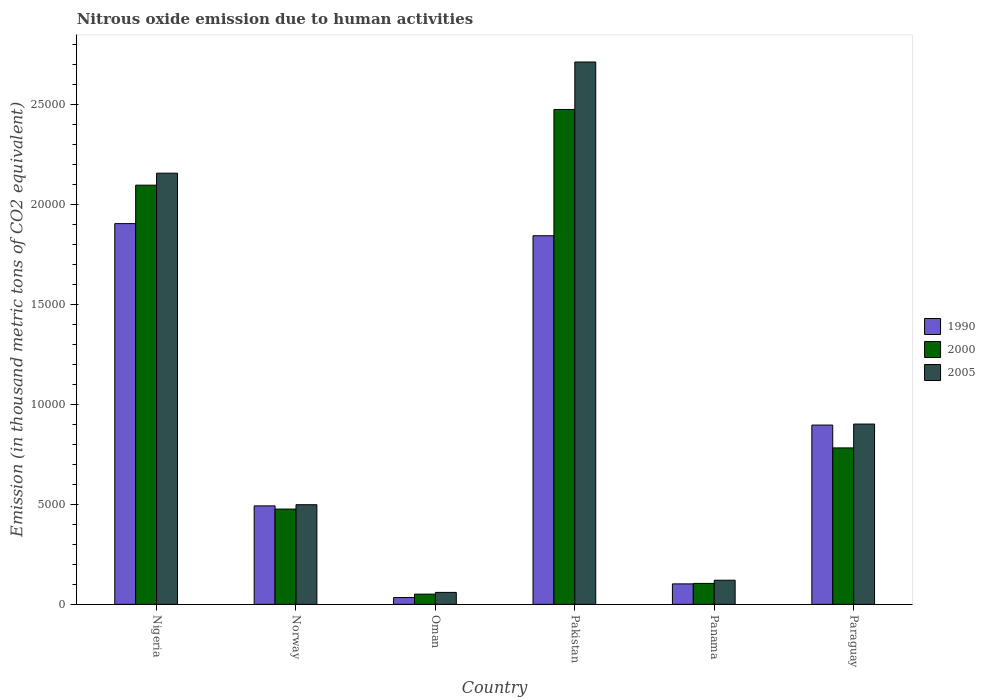How many different coloured bars are there?
Offer a terse response. 3. How many groups of bars are there?
Offer a terse response. 6. What is the label of the 6th group of bars from the left?
Offer a very short reply. Paraguay. In how many cases, is the number of bars for a given country not equal to the number of legend labels?
Your answer should be compact. 0. What is the amount of nitrous oxide emitted in 2000 in Oman?
Keep it short and to the point. 510.6. Across all countries, what is the maximum amount of nitrous oxide emitted in 2005?
Offer a terse response. 2.71e+04. Across all countries, what is the minimum amount of nitrous oxide emitted in 2005?
Your answer should be compact. 597.3. In which country was the amount of nitrous oxide emitted in 2000 minimum?
Your answer should be compact. Oman. What is the total amount of nitrous oxide emitted in 2005 in the graph?
Provide a short and direct response. 6.45e+04. What is the difference between the amount of nitrous oxide emitted in 1990 in Pakistan and that in Panama?
Offer a terse response. 1.74e+04. What is the difference between the amount of nitrous oxide emitted in 2000 in Pakistan and the amount of nitrous oxide emitted in 1990 in Paraguay?
Give a very brief answer. 1.58e+04. What is the average amount of nitrous oxide emitted in 1990 per country?
Ensure brevity in your answer.  8790.95. What is the difference between the amount of nitrous oxide emitted of/in 1990 and amount of nitrous oxide emitted of/in 2000 in Norway?
Provide a short and direct response. 159.5. In how many countries, is the amount of nitrous oxide emitted in 1990 greater than 19000 thousand metric tons?
Provide a succinct answer. 1. What is the ratio of the amount of nitrous oxide emitted in 2005 in Panama to that in Paraguay?
Keep it short and to the point. 0.13. Is the amount of nitrous oxide emitted in 1990 in Norway less than that in Oman?
Provide a succinct answer. No. Is the difference between the amount of nitrous oxide emitted in 1990 in Norway and Panama greater than the difference between the amount of nitrous oxide emitted in 2000 in Norway and Panama?
Your answer should be very brief. Yes. What is the difference between the highest and the second highest amount of nitrous oxide emitted in 2005?
Keep it short and to the point. -1.26e+04. What is the difference between the highest and the lowest amount of nitrous oxide emitted in 2000?
Your answer should be compact. 2.42e+04. In how many countries, is the amount of nitrous oxide emitted in 2000 greater than the average amount of nitrous oxide emitted in 2000 taken over all countries?
Offer a very short reply. 2. Is the sum of the amount of nitrous oxide emitted in 2005 in Norway and Pakistan greater than the maximum amount of nitrous oxide emitted in 1990 across all countries?
Keep it short and to the point. Yes. What does the 2nd bar from the left in Paraguay represents?
Your answer should be compact. 2000. What does the 3rd bar from the right in Oman represents?
Provide a short and direct response. 1990. How many countries are there in the graph?
Keep it short and to the point. 6. What is the difference between two consecutive major ticks on the Y-axis?
Offer a terse response. 5000. Are the values on the major ticks of Y-axis written in scientific E-notation?
Make the answer very short. No. Does the graph contain any zero values?
Make the answer very short. No. Where does the legend appear in the graph?
Your answer should be compact. Center right. What is the title of the graph?
Your answer should be very brief. Nitrous oxide emission due to human activities. Does "2003" appear as one of the legend labels in the graph?
Offer a very short reply. No. What is the label or title of the Y-axis?
Ensure brevity in your answer.  Emission (in thousand metric tons of CO2 equivalent). What is the Emission (in thousand metric tons of CO2 equivalent) of 1990 in Nigeria?
Your answer should be very brief. 1.90e+04. What is the Emission (in thousand metric tons of CO2 equivalent) in 2000 in Nigeria?
Offer a terse response. 2.10e+04. What is the Emission (in thousand metric tons of CO2 equivalent) of 2005 in Nigeria?
Make the answer very short. 2.16e+04. What is the Emission (in thousand metric tons of CO2 equivalent) in 1990 in Norway?
Provide a succinct answer. 4925.7. What is the Emission (in thousand metric tons of CO2 equivalent) in 2000 in Norway?
Give a very brief answer. 4766.2. What is the Emission (in thousand metric tons of CO2 equivalent) in 2005 in Norway?
Provide a short and direct response. 4984.5. What is the Emission (in thousand metric tons of CO2 equivalent) in 1990 in Oman?
Make the answer very short. 338.2. What is the Emission (in thousand metric tons of CO2 equivalent) in 2000 in Oman?
Provide a short and direct response. 510.6. What is the Emission (in thousand metric tons of CO2 equivalent) in 2005 in Oman?
Give a very brief answer. 597.3. What is the Emission (in thousand metric tons of CO2 equivalent) in 1990 in Pakistan?
Keep it short and to the point. 1.84e+04. What is the Emission (in thousand metric tons of CO2 equivalent) of 2000 in Pakistan?
Your answer should be very brief. 2.48e+04. What is the Emission (in thousand metric tons of CO2 equivalent) of 2005 in Pakistan?
Provide a short and direct response. 2.71e+04. What is the Emission (in thousand metric tons of CO2 equivalent) of 1990 in Panama?
Your answer should be compact. 1023.3. What is the Emission (in thousand metric tons of CO2 equivalent) in 2000 in Panama?
Keep it short and to the point. 1046.4. What is the Emission (in thousand metric tons of CO2 equivalent) in 2005 in Panama?
Provide a succinct answer. 1207.1. What is the Emission (in thousand metric tons of CO2 equivalent) in 1990 in Paraguay?
Provide a succinct answer. 8968.7. What is the Emission (in thousand metric tons of CO2 equivalent) in 2000 in Paraguay?
Give a very brief answer. 7826.3. What is the Emission (in thousand metric tons of CO2 equivalent) in 2005 in Paraguay?
Keep it short and to the point. 9019.7. Across all countries, what is the maximum Emission (in thousand metric tons of CO2 equivalent) in 1990?
Keep it short and to the point. 1.90e+04. Across all countries, what is the maximum Emission (in thousand metric tons of CO2 equivalent) in 2000?
Your response must be concise. 2.48e+04. Across all countries, what is the maximum Emission (in thousand metric tons of CO2 equivalent) in 2005?
Ensure brevity in your answer.  2.71e+04. Across all countries, what is the minimum Emission (in thousand metric tons of CO2 equivalent) of 1990?
Provide a succinct answer. 338.2. Across all countries, what is the minimum Emission (in thousand metric tons of CO2 equivalent) of 2000?
Ensure brevity in your answer.  510.6. Across all countries, what is the minimum Emission (in thousand metric tons of CO2 equivalent) of 2005?
Your answer should be compact. 597.3. What is the total Emission (in thousand metric tons of CO2 equivalent) in 1990 in the graph?
Your answer should be compact. 5.27e+04. What is the total Emission (in thousand metric tons of CO2 equivalent) in 2000 in the graph?
Ensure brevity in your answer.  5.99e+04. What is the total Emission (in thousand metric tons of CO2 equivalent) of 2005 in the graph?
Provide a short and direct response. 6.45e+04. What is the difference between the Emission (in thousand metric tons of CO2 equivalent) in 1990 in Nigeria and that in Norway?
Offer a terse response. 1.41e+04. What is the difference between the Emission (in thousand metric tons of CO2 equivalent) of 2000 in Nigeria and that in Norway?
Ensure brevity in your answer.  1.62e+04. What is the difference between the Emission (in thousand metric tons of CO2 equivalent) of 2005 in Nigeria and that in Norway?
Provide a short and direct response. 1.66e+04. What is the difference between the Emission (in thousand metric tons of CO2 equivalent) in 1990 in Nigeria and that in Oman?
Your response must be concise. 1.87e+04. What is the difference between the Emission (in thousand metric tons of CO2 equivalent) of 2000 in Nigeria and that in Oman?
Offer a very short reply. 2.05e+04. What is the difference between the Emission (in thousand metric tons of CO2 equivalent) of 2005 in Nigeria and that in Oman?
Provide a succinct answer. 2.10e+04. What is the difference between the Emission (in thousand metric tons of CO2 equivalent) in 1990 in Nigeria and that in Pakistan?
Offer a very short reply. 606.4. What is the difference between the Emission (in thousand metric tons of CO2 equivalent) in 2000 in Nigeria and that in Pakistan?
Offer a terse response. -3787.6. What is the difference between the Emission (in thousand metric tons of CO2 equivalent) in 2005 in Nigeria and that in Pakistan?
Provide a short and direct response. -5562. What is the difference between the Emission (in thousand metric tons of CO2 equivalent) of 1990 in Nigeria and that in Panama?
Your answer should be very brief. 1.80e+04. What is the difference between the Emission (in thousand metric tons of CO2 equivalent) of 2000 in Nigeria and that in Panama?
Keep it short and to the point. 1.99e+04. What is the difference between the Emission (in thousand metric tons of CO2 equivalent) in 2005 in Nigeria and that in Panama?
Your answer should be very brief. 2.04e+04. What is the difference between the Emission (in thousand metric tons of CO2 equivalent) of 1990 in Nigeria and that in Paraguay?
Offer a terse response. 1.01e+04. What is the difference between the Emission (in thousand metric tons of CO2 equivalent) in 2000 in Nigeria and that in Paraguay?
Keep it short and to the point. 1.31e+04. What is the difference between the Emission (in thousand metric tons of CO2 equivalent) in 2005 in Nigeria and that in Paraguay?
Make the answer very short. 1.26e+04. What is the difference between the Emission (in thousand metric tons of CO2 equivalent) in 1990 in Norway and that in Oman?
Make the answer very short. 4587.5. What is the difference between the Emission (in thousand metric tons of CO2 equivalent) in 2000 in Norway and that in Oman?
Offer a very short reply. 4255.6. What is the difference between the Emission (in thousand metric tons of CO2 equivalent) of 2005 in Norway and that in Oman?
Give a very brief answer. 4387.2. What is the difference between the Emission (in thousand metric tons of CO2 equivalent) of 1990 in Norway and that in Pakistan?
Provide a short and direct response. -1.35e+04. What is the difference between the Emission (in thousand metric tons of CO2 equivalent) of 2000 in Norway and that in Pakistan?
Provide a succinct answer. -2.00e+04. What is the difference between the Emission (in thousand metric tons of CO2 equivalent) in 2005 in Norway and that in Pakistan?
Provide a succinct answer. -2.22e+04. What is the difference between the Emission (in thousand metric tons of CO2 equivalent) in 1990 in Norway and that in Panama?
Make the answer very short. 3902.4. What is the difference between the Emission (in thousand metric tons of CO2 equivalent) in 2000 in Norway and that in Panama?
Your response must be concise. 3719.8. What is the difference between the Emission (in thousand metric tons of CO2 equivalent) in 2005 in Norway and that in Panama?
Ensure brevity in your answer.  3777.4. What is the difference between the Emission (in thousand metric tons of CO2 equivalent) in 1990 in Norway and that in Paraguay?
Keep it short and to the point. -4043. What is the difference between the Emission (in thousand metric tons of CO2 equivalent) in 2000 in Norway and that in Paraguay?
Keep it short and to the point. -3060.1. What is the difference between the Emission (in thousand metric tons of CO2 equivalent) of 2005 in Norway and that in Paraguay?
Give a very brief answer. -4035.2. What is the difference between the Emission (in thousand metric tons of CO2 equivalent) of 1990 in Oman and that in Pakistan?
Provide a succinct answer. -1.81e+04. What is the difference between the Emission (in thousand metric tons of CO2 equivalent) in 2000 in Oman and that in Pakistan?
Ensure brevity in your answer.  -2.42e+04. What is the difference between the Emission (in thousand metric tons of CO2 equivalent) in 2005 in Oman and that in Pakistan?
Your answer should be compact. -2.65e+04. What is the difference between the Emission (in thousand metric tons of CO2 equivalent) in 1990 in Oman and that in Panama?
Your answer should be very brief. -685.1. What is the difference between the Emission (in thousand metric tons of CO2 equivalent) in 2000 in Oman and that in Panama?
Provide a succinct answer. -535.8. What is the difference between the Emission (in thousand metric tons of CO2 equivalent) in 2005 in Oman and that in Panama?
Ensure brevity in your answer.  -609.8. What is the difference between the Emission (in thousand metric tons of CO2 equivalent) of 1990 in Oman and that in Paraguay?
Your answer should be compact. -8630.5. What is the difference between the Emission (in thousand metric tons of CO2 equivalent) in 2000 in Oman and that in Paraguay?
Keep it short and to the point. -7315.7. What is the difference between the Emission (in thousand metric tons of CO2 equivalent) in 2005 in Oman and that in Paraguay?
Provide a succinct answer. -8422.4. What is the difference between the Emission (in thousand metric tons of CO2 equivalent) in 1990 in Pakistan and that in Panama?
Keep it short and to the point. 1.74e+04. What is the difference between the Emission (in thousand metric tons of CO2 equivalent) of 2000 in Pakistan and that in Panama?
Give a very brief answer. 2.37e+04. What is the difference between the Emission (in thousand metric tons of CO2 equivalent) of 2005 in Pakistan and that in Panama?
Make the answer very short. 2.59e+04. What is the difference between the Emission (in thousand metric tons of CO2 equivalent) of 1990 in Pakistan and that in Paraguay?
Your answer should be compact. 9473. What is the difference between the Emission (in thousand metric tons of CO2 equivalent) of 2000 in Pakistan and that in Paraguay?
Your answer should be very brief. 1.69e+04. What is the difference between the Emission (in thousand metric tons of CO2 equivalent) in 2005 in Pakistan and that in Paraguay?
Give a very brief answer. 1.81e+04. What is the difference between the Emission (in thousand metric tons of CO2 equivalent) in 1990 in Panama and that in Paraguay?
Provide a succinct answer. -7945.4. What is the difference between the Emission (in thousand metric tons of CO2 equivalent) of 2000 in Panama and that in Paraguay?
Offer a terse response. -6779.9. What is the difference between the Emission (in thousand metric tons of CO2 equivalent) in 2005 in Panama and that in Paraguay?
Your response must be concise. -7812.6. What is the difference between the Emission (in thousand metric tons of CO2 equivalent) in 1990 in Nigeria and the Emission (in thousand metric tons of CO2 equivalent) in 2000 in Norway?
Your answer should be very brief. 1.43e+04. What is the difference between the Emission (in thousand metric tons of CO2 equivalent) of 1990 in Nigeria and the Emission (in thousand metric tons of CO2 equivalent) of 2005 in Norway?
Offer a very short reply. 1.41e+04. What is the difference between the Emission (in thousand metric tons of CO2 equivalent) in 2000 in Nigeria and the Emission (in thousand metric tons of CO2 equivalent) in 2005 in Norway?
Your response must be concise. 1.60e+04. What is the difference between the Emission (in thousand metric tons of CO2 equivalent) in 1990 in Nigeria and the Emission (in thousand metric tons of CO2 equivalent) in 2000 in Oman?
Keep it short and to the point. 1.85e+04. What is the difference between the Emission (in thousand metric tons of CO2 equivalent) in 1990 in Nigeria and the Emission (in thousand metric tons of CO2 equivalent) in 2005 in Oman?
Keep it short and to the point. 1.85e+04. What is the difference between the Emission (in thousand metric tons of CO2 equivalent) in 2000 in Nigeria and the Emission (in thousand metric tons of CO2 equivalent) in 2005 in Oman?
Offer a very short reply. 2.04e+04. What is the difference between the Emission (in thousand metric tons of CO2 equivalent) of 1990 in Nigeria and the Emission (in thousand metric tons of CO2 equivalent) of 2000 in Pakistan?
Your answer should be compact. -5711.6. What is the difference between the Emission (in thousand metric tons of CO2 equivalent) of 1990 in Nigeria and the Emission (in thousand metric tons of CO2 equivalent) of 2005 in Pakistan?
Provide a short and direct response. -8086.4. What is the difference between the Emission (in thousand metric tons of CO2 equivalent) in 2000 in Nigeria and the Emission (in thousand metric tons of CO2 equivalent) in 2005 in Pakistan?
Your response must be concise. -6162.4. What is the difference between the Emission (in thousand metric tons of CO2 equivalent) in 1990 in Nigeria and the Emission (in thousand metric tons of CO2 equivalent) in 2000 in Panama?
Offer a very short reply. 1.80e+04. What is the difference between the Emission (in thousand metric tons of CO2 equivalent) of 1990 in Nigeria and the Emission (in thousand metric tons of CO2 equivalent) of 2005 in Panama?
Your response must be concise. 1.78e+04. What is the difference between the Emission (in thousand metric tons of CO2 equivalent) in 2000 in Nigeria and the Emission (in thousand metric tons of CO2 equivalent) in 2005 in Panama?
Your answer should be very brief. 1.98e+04. What is the difference between the Emission (in thousand metric tons of CO2 equivalent) in 1990 in Nigeria and the Emission (in thousand metric tons of CO2 equivalent) in 2000 in Paraguay?
Offer a very short reply. 1.12e+04. What is the difference between the Emission (in thousand metric tons of CO2 equivalent) of 1990 in Nigeria and the Emission (in thousand metric tons of CO2 equivalent) of 2005 in Paraguay?
Offer a terse response. 1.00e+04. What is the difference between the Emission (in thousand metric tons of CO2 equivalent) of 2000 in Nigeria and the Emission (in thousand metric tons of CO2 equivalent) of 2005 in Paraguay?
Give a very brief answer. 1.20e+04. What is the difference between the Emission (in thousand metric tons of CO2 equivalent) in 1990 in Norway and the Emission (in thousand metric tons of CO2 equivalent) in 2000 in Oman?
Your answer should be very brief. 4415.1. What is the difference between the Emission (in thousand metric tons of CO2 equivalent) in 1990 in Norway and the Emission (in thousand metric tons of CO2 equivalent) in 2005 in Oman?
Provide a succinct answer. 4328.4. What is the difference between the Emission (in thousand metric tons of CO2 equivalent) of 2000 in Norway and the Emission (in thousand metric tons of CO2 equivalent) of 2005 in Oman?
Ensure brevity in your answer.  4168.9. What is the difference between the Emission (in thousand metric tons of CO2 equivalent) of 1990 in Norway and the Emission (in thousand metric tons of CO2 equivalent) of 2000 in Pakistan?
Offer a very short reply. -1.98e+04. What is the difference between the Emission (in thousand metric tons of CO2 equivalent) of 1990 in Norway and the Emission (in thousand metric tons of CO2 equivalent) of 2005 in Pakistan?
Your answer should be very brief. -2.22e+04. What is the difference between the Emission (in thousand metric tons of CO2 equivalent) of 2000 in Norway and the Emission (in thousand metric tons of CO2 equivalent) of 2005 in Pakistan?
Provide a short and direct response. -2.24e+04. What is the difference between the Emission (in thousand metric tons of CO2 equivalent) of 1990 in Norway and the Emission (in thousand metric tons of CO2 equivalent) of 2000 in Panama?
Your response must be concise. 3879.3. What is the difference between the Emission (in thousand metric tons of CO2 equivalent) of 1990 in Norway and the Emission (in thousand metric tons of CO2 equivalent) of 2005 in Panama?
Ensure brevity in your answer.  3718.6. What is the difference between the Emission (in thousand metric tons of CO2 equivalent) in 2000 in Norway and the Emission (in thousand metric tons of CO2 equivalent) in 2005 in Panama?
Give a very brief answer. 3559.1. What is the difference between the Emission (in thousand metric tons of CO2 equivalent) of 1990 in Norway and the Emission (in thousand metric tons of CO2 equivalent) of 2000 in Paraguay?
Offer a very short reply. -2900.6. What is the difference between the Emission (in thousand metric tons of CO2 equivalent) in 1990 in Norway and the Emission (in thousand metric tons of CO2 equivalent) in 2005 in Paraguay?
Keep it short and to the point. -4094. What is the difference between the Emission (in thousand metric tons of CO2 equivalent) of 2000 in Norway and the Emission (in thousand metric tons of CO2 equivalent) of 2005 in Paraguay?
Your response must be concise. -4253.5. What is the difference between the Emission (in thousand metric tons of CO2 equivalent) of 1990 in Oman and the Emission (in thousand metric tons of CO2 equivalent) of 2000 in Pakistan?
Your response must be concise. -2.44e+04. What is the difference between the Emission (in thousand metric tons of CO2 equivalent) in 1990 in Oman and the Emission (in thousand metric tons of CO2 equivalent) in 2005 in Pakistan?
Keep it short and to the point. -2.68e+04. What is the difference between the Emission (in thousand metric tons of CO2 equivalent) of 2000 in Oman and the Emission (in thousand metric tons of CO2 equivalent) of 2005 in Pakistan?
Provide a succinct answer. -2.66e+04. What is the difference between the Emission (in thousand metric tons of CO2 equivalent) in 1990 in Oman and the Emission (in thousand metric tons of CO2 equivalent) in 2000 in Panama?
Provide a succinct answer. -708.2. What is the difference between the Emission (in thousand metric tons of CO2 equivalent) in 1990 in Oman and the Emission (in thousand metric tons of CO2 equivalent) in 2005 in Panama?
Your response must be concise. -868.9. What is the difference between the Emission (in thousand metric tons of CO2 equivalent) in 2000 in Oman and the Emission (in thousand metric tons of CO2 equivalent) in 2005 in Panama?
Make the answer very short. -696.5. What is the difference between the Emission (in thousand metric tons of CO2 equivalent) in 1990 in Oman and the Emission (in thousand metric tons of CO2 equivalent) in 2000 in Paraguay?
Your answer should be very brief. -7488.1. What is the difference between the Emission (in thousand metric tons of CO2 equivalent) in 1990 in Oman and the Emission (in thousand metric tons of CO2 equivalent) in 2005 in Paraguay?
Give a very brief answer. -8681.5. What is the difference between the Emission (in thousand metric tons of CO2 equivalent) in 2000 in Oman and the Emission (in thousand metric tons of CO2 equivalent) in 2005 in Paraguay?
Ensure brevity in your answer.  -8509.1. What is the difference between the Emission (in thousand metric tons of CO2 equivalent) of 1990 in Pakistan and the Emission (in thousand metric tons of CO2 equivalent) of 2000 in Panama?
Your answer should be very brief. 1.74e+04. What is the difference between the Emission (in thousand metric tons of CO2 equivalent) in 1990 in Pakistan and the Emission (in thousand metric tons of CO2 equivalent) in 2005 in Panama?
Your answer should be compact. 1.72e+04. What is the difference between the Emission (in thousand metric tons of CO2 equivalent) of 2000 in Pakistan and the Emission (in thousand metric tons of CO2 equivalent) of 2005 in Panama?
Your answer should be compact. 2.36e+04. What is the difference between the Emission (in thousand metric tons of CO2 equivalent) in 1990 in Pakistan and the Emission (in thousand metric tons of CO2 equivalent) in 2000 in Paraguay?
Offer a terse response. 1.06e+04. What is the difference between the Emission (in thousand metric tons of CO2 equivalent) in 1990 in Pakistan and the Emission (in thousand metric tons of CO2 equivalent) in 2005 in Paraguay?
Provide a succinct answer. 9422. What is the difference between the Emission (in thousand metric tons of CO2 equivalent) in 2000 in Pakistan and the Emission (in thousand metric tons of CO2 equivalent) in 2005 in Paraguay?
Offer a terse response. 1.57e+04. What is the difference between the Emission (in thousand metric tons of CO2 equivalent) in 1990 in Panama and the Emission (in thousand metric tons of CO2 equivalent) in 2000 in Paraguay?
Offer a very short reply. -6803. What is the difference between the Emission (in thousand metric tons of CO2 equivalent) of 1990 in Panama and the Emission (in thousand metric tons of CO2 equivalent) of 2005 in Paraguay?
Provide a succinct answer. -7996.4. What is the difference between the Emission (in thousand metric tons of CO2 equivalent) of 2000 in Panama and the Emission (in thousand metric tons of CO2 equivalent) of 2005 in Paraguay?
Give a very brief answer. -7973.3. What is the average Emission (in thousand metric tons of CO2 equivalent) in 1990 per country?
Provide a succinct answer. 8790.95. What is the average Emission (in thousand metric tons of CO2 equivalent) in 2000 per country?
Offer a terse response. 9980.22. What is the average Emission (in thousand metric tons of CO2 equivalent) of 2005 per country?
Your response must be concise. 1.08e+04. What is the difference between the Emission (in thousand metric tons of CO2 equivalent) in 1990 and Emission (in thousand metric tons of CO2 equivalent) in 2000 in Nigeria?
Keep it short and to the point. -1924. What is the difference between the Emission (in thousand metric tons of CO2 equivalent) of 1990 and Emission (in thousand metric tons of CO2 equivalent) of 2005 in Nigeria?
Your response must be concise. -2524.4. What is the difference between the Emission (in thousand metric tons of CO2 equivalent) of 2000 and Emission (in thousand metric tons of CO2 equivalent) of 2005 in Nigeria?
Offer a terse response. -600.4. What is the difference between the Emission (in thousand metric tons of CO2 equivalent) in 1990 and Emission (in thousand metric tons of CO2 equivalent) in 2000 in Norway?
Give a very brief answer. 159.5. What is the difference between the Emission (in thousand metric tons of CO2 equivalent) in 1990 and Emission (in thousand metric tons of CO2 equivalent) in 2005 in Norway?
Make the answer very short. -58.8. What is the difference between the Emission (in thousand metric tons of CO2 equivalent) in 2000 and Emission (in thousand metric tons of CO2 equivalent) in 2005 in Norway?
Keep it short and to the point. -218.3. What is the difference between the Emission (in thousand metric tons of CO2 equivalent) of 1990 and Emission (in thousand metric tons of CO2 equivalent) of 2000 in Oman?
Provide a short and direct response. -172.4. What is the difference between the Emission (in thousand metric tons of CO2 equivalent) of 1990 and Emission (in thousand metric tons of CO2 equivalent) of 2005 in Oman?
Keep it short and to the point. -259.1. What is the difference between the Emission (in thousand metric tons of CO2 equivalent) of 2000 and Emission (in thousand metric tons of CO2 equivalent) of 2005 in Oman?
Offer a terse response. -86.7. What is the difference between the Emission (in thousand metric tons of CO2 equivalent) in 1990 and Emission (in thousand metric tons of CO2 equivalent) in 2000 in Pakistan?
Make the answer very short. -6318. What is the difference between the Emission (in thousand metric tons of CO2 equivalent) of 1990 and Emission (in thousand metric tons of CO2 equivalent) of 2005 in Pakistan?
Your answer should be compact. -8692.8. What is the difference between the Emission (in thousand metric tons of CO2 equivalent) of 2000 and Emission (in thousand metric tons of CO2 equivalent) of 2005 in Pakistan?
Provide a succinct answer. -2374.8. What is the difference between the Emission (in thousand metric tons of CO2 equivalent) of 1990 and Emission (in thousand metric tons of CO2 equivalent) of 2000 in Panama?
Make the answer very short. -23.1. What is the difference between the Emission (in thousand metric tons of CO2 equivalent) of 1990 and Emission (in thousand metric tons of CO2 equivalent) of 2005 in Panama?
Provide a succinct answer. -183.8. What is the difference between the Emission (in thousand metric tons of CO2 equivalent) in 2000 and Emission (in thousand metric tons of CO2 equivalent) in 2005 in Panama?
Your answer should be very brief. -160.7. What is the difference between the Emission (in thousand metric tons of CO2 equivalent) of 1990 and Emission (in thousand metric tons of CO2 equivalent) of 2000 in Paraguay?
Give a very brief answer. 1142.4. What is the difference between the Emission (in thousand metric tons of CO2 equivalent) in 1990 and Emission (in thousand metric tons of CO2 equivalent) in 2005 in Paraguay?
Make the answer very short. -51. What is the difference between the Emission (in thousand metric tons of CO2 equivalent) of 2000 and Emission (in thousand metric tons of CO2 equivalent) of 2005 in Paraguay?
Offer a terse response. -1193.4. What is the ratio of the Emission (in thousand metric tons of CO2 equivalent) in 1990 in Nigeria to that in Norway?
Your response must be concise. 3.87. What is the ratio of the Emission (in thousand metric tons of CO2 equivalent) of 2000 in Nigeria to that in Norway?
Your response must be concise. 4.4. What is the ratio of the Emission (in thousand metric tons of CO2 equivalent) in 2005 in Nigeria to that in Norway?
Offer a terse response. 4.33. What is the ratio of the Emission (in thousand metric tons of CO2 equivalent) in 1990 in Nigeria to that in Oman?
Offer a very short reply. 56.32. What is the ratio of the Emission (in thousand metric tons of CO2 equivalent) of 2000 in Nigeria to that in Oman?
Give a very brief answer. 41.07. What is the ratio of the Emission (in thousand metric tons of CO2 equivalent) in 2005 in Nigeria to that in Oman?
Ensure brevity in your answer.  36.12. What is the ratio of the Emission (in thousand metric tons of CO2 equivalent) of 1990 in Nigeria to that in Pakistan?
Provide a short and direct response. 1.03. What is the ratio of the Emission (in thousand metric tons of CO2 equivalent) of 2000 in Nigeria to that in Pakistan?
Make the answer very short. 0.85. What is the ratio of the Emission (in thousand metric tons of CO2 equivalent) in 2005 in Nigeria to that in Pakistan?
Provide a short and direct response. 0.8. What is the ratio of the Emission (in thousand metric tons of CO2 equivalent) in 1990 in Nigeria to that in Panama?
Provide a succinct answer. 18.61. What is the ratio of the Emission (in thousand metric tons of CO2 equivalent) of 2000 in Nigeria to that in Panama?
Provide a succinct answer. 20.04. What is the ratio of the Emission (in thousand metric tons of CO2 equivalent) of 2005 in Nigeria to that in Panama?
Your response must be concise. 17.87. What is the ratio of the Emission (in thousand metric tons of CO2 equivalent) of 1990 in Nigeria to that in Paraguay?
Ensure brevity in your answer.  2.12. What is the ratio of the Emission (in thousand metric tons of CO2 equivalent) of 2000 in Nigeria to that in Paraguay?
Offer a terse response. 2.68. What is the ratio of the Emission (in thousand metric tons of CO2 equivalent) of 2005 in Nigeria to that in Paraguay?
Your answer should be compact. 2.39. What is the ratio of the Emission (in thousand metric tons of CO2 equivalent) in 1990 in Norway to that in Oman?
Provide a short and direct response. 14.56. What is the ratio of the Emission (in thousand metric tons of CO2 equivalent) of 2000 in Norway to that in Oman?
Your answer should be very brief. 9.33. What is the ratio of the Emission (in thousand metric tons of CO2 equivalent) in 2005 in Norway to that in Oman?
Keep it short and to the point. 8.35. What is the ratio of the Emission (in thousand metric tons of CO2 equivalent) of 1990 in Norway to that in Pakistan?
Your response must be concise. 0.27. What is the ratio of the Emission (in thousand metric tons of CO2 equivalent) of 2000 in Norway to that in Pakistan?
Your response must be concise. 0.19. What is the ratio of the Emission (in thousand metric tons of CO2 equivalent) in 2005 in Norway to that in Pakistan?
Offer a very short reply. 0.18. What is the ratio of the Emission (in thousand metric tons of CO2 equivalent) of 1990 in Norway to that in Panama?
Provide a succinct answer. 4.81. What is the ratio of the Emission (in thousand metric tons of CO2 equivalent) of 2000 in Norway to that in Panama?
Offer a terse response. 4.55. What is the ratio of the Emission (in thousand metric tons of CO2 equivalent) of 2005 in Norway to that in Panama?
Keep it short and to the point. 4.13. What is the ratio of the Emission (in thousand metric tons of CO2 equivalent) of 1990 in Norway to that in Paraguay?
Your response must be concise. 0.55. What is the ratio of the Emission (in thousand metric tons of CO2 equivalent) of 2000 in Norway to that in Paraguay?
Your response must be concise. 0.61. What is the ratio of the Emission (in thousand metric tons of CO2 equivalent) in 2005 in Norway to that in Paraguay?
Provide a succinct answer. 0.55. What is the ratio of the Emission (in thousand metric tons of CO2 equivalent) of 1990 in Oman to that in Pakistan?
Offer a terse response. 0.02. What is the ratio of the Emission (in thousand metric tons of CO2 equivalent) of 2000 in Oman to that in Pakistan?
Your answer should be compact. 0.02. What is the ratio of the Emission (in thousand metric tons of CO2 equivalent) of 2005 in Oman to that in Pakistan?
Provide a short and direct response. 0.02. What is the ratio of the Emission (in thousand metric tons of CO2 equivalent) of 1990 in Oman to that in Panama?
Make the answer very short. 0.33. What is the ratio of the Emission (in thousand metric tons of CO2 equivalent) in 2000 in Oman to that in Panama?
Provide a short and direct response. 0.49. What is the ratio of the Emission (in thousand metric tons of CO2 equivalent) in 2005 in Oman to that in Panama?
Your response must be concise. 0.49. What is the ratio of the Emission (in thousand metric tons of CO2 equivalent) of 1990 in Oman to that in Paraguay?
Provide a short and direct response. 0.04. What is the ratio of the Emission (in thousand metric tons of CO2 equivalent) of 2000 in Oman to that in Paraguay?
Your response must be concise. 0.07. What is the ratio of the Emission (in thousand metric tons of CO2 equivalent) in 2005 in Oman to that in Paraguay?
Your response must be concise. 0.07. What is the ratio of the Emission (in thousand metric tons of CO2 equivalent) in 1990 in Pakistan to that in Panama?
Offer a terse response. 18.02. What is the ratio of the Emission (in thousand metric tons of CO2 equivalent) of 2000 in Pakistan to that in Panama?
Keep it short and to the point. 23.66. What is the ratio of the Emission (in thousand metric tons of CO2 equivalent) of 2005 in Pakistan to that in Panama?
Provide a succinct answer. 22.48. What is the ratio of the Emission (in thousand metric tons of CO2 equivalent) in 1990 in Pakistan to that in Paraguay?
Your answer should be very brief. 2.06. What is the ratio of the Emission (in thousand metric tons of CO2 equivalent) of 2000 in Pakistan to that in Paraguay?
Keep it short and to the point. 3.16. What is the ratio of the Emission (in thousand metric tons of CO2 equivalent) of 2005 in Pakistan to that in Paraguay?
Offer a very short reply. 3.01. What is the ratio of the Emission (in thousand metric tons of CO2 equivalent) in 1990 in Panama to that in Paraguay?
Provide a short and direct response. 0.11. What is the ratio of the Emission (in thousand metric tons of CO2 equivalent) of 2000 in Panama to that in Paraguay?
Offer a very short reply. 0.13. What is the ratio of the Emission (in thousand metric tons of CO2 equivalent) in 2005 in Panama to that in Paraguay?
Your response must be concise. 0.13. What is the difference between the highest and the second highest Emission (in thousand metric tons of CO2 equivalent) of 1990?
Your answer should be compact. 606.4. What is the difference between the highest and the second highest Emission (in thousand metric tons of CO2 equivalent) in 2000?
Your answer should be very brief. 3787.6. What is the difference between the highest and the second highest Emission (in thousand metric tons of CO2 equivalent) of 2005?
Your answer should be very brief. 5562. What is the difference between the highest and the lowest Emission (in thousand metric tons of CO2 equivalent) of 1990?
Provide a succinct answer. 1.87e+04. What is the difference between the highest and the lowest Emission (in thousand metric tons of CO2 equivalent) of 2000?
Provide a succinct answer. 2.42e+04. What is the difference between the highest and the lowest Emission (in thousand metric tons of CO2 equivalent) of 2005?
Make the answer very short. 2.65e+04. 